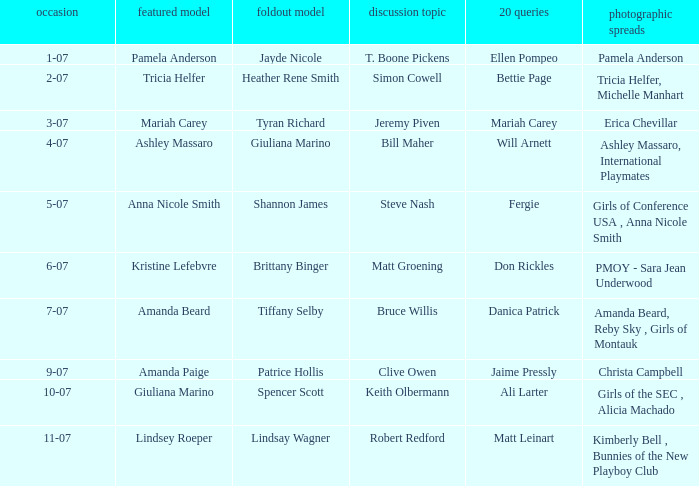Who was the centerfold model in the issue where Fergie answered the "20 questions"? Shannon James. 